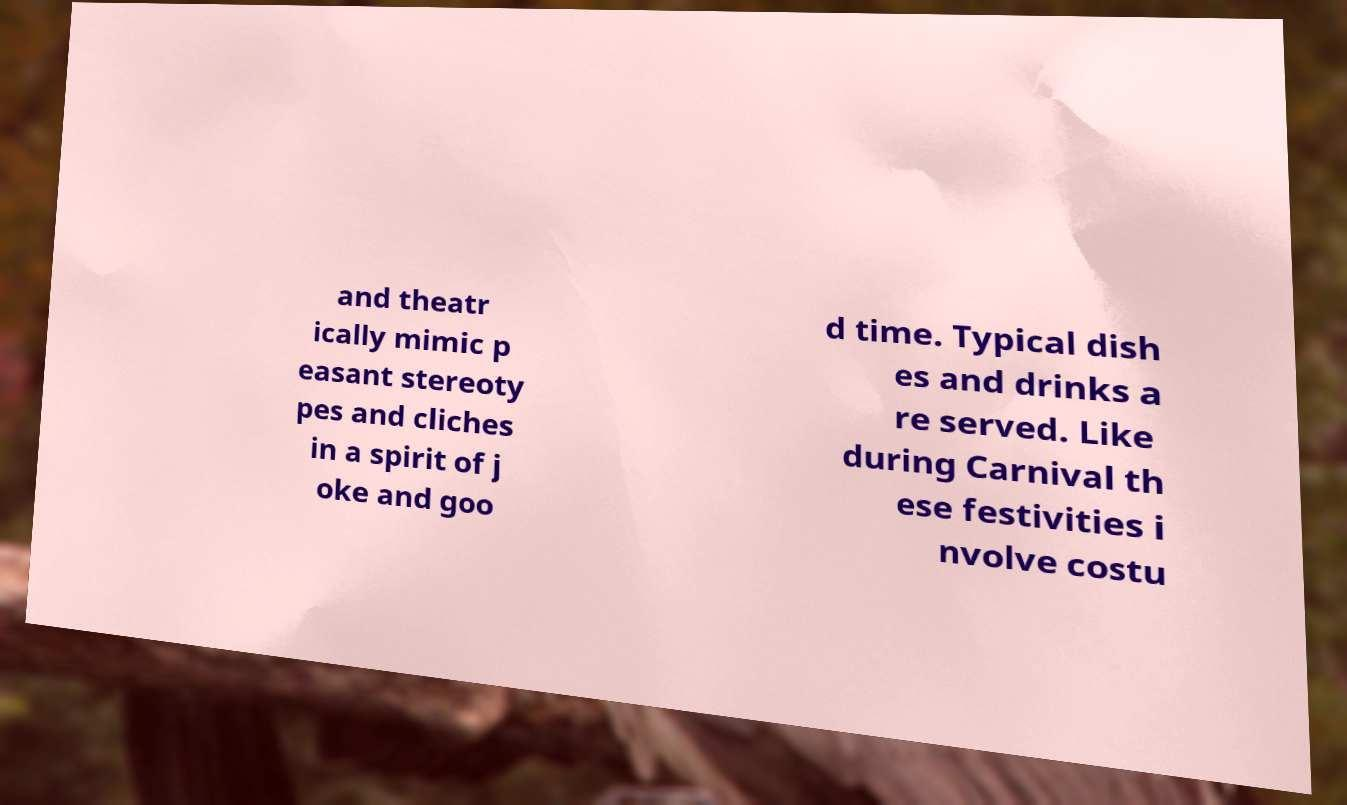There's text embedded in this image that I need extracted. Can you transcribe it verbatim? and theatr ically mimic p easant stereoty pes and cliches in a spirit of j oke and goo d time. Typical dish es and drinks a re served. Like during Carnival th ese festivities i nvolve costu 